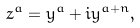<formula> <loc_0><loc_0><loc_500><loc_500>z ^ { a } = y ^ { a } + i y ^ { a + n } ,</formula> 